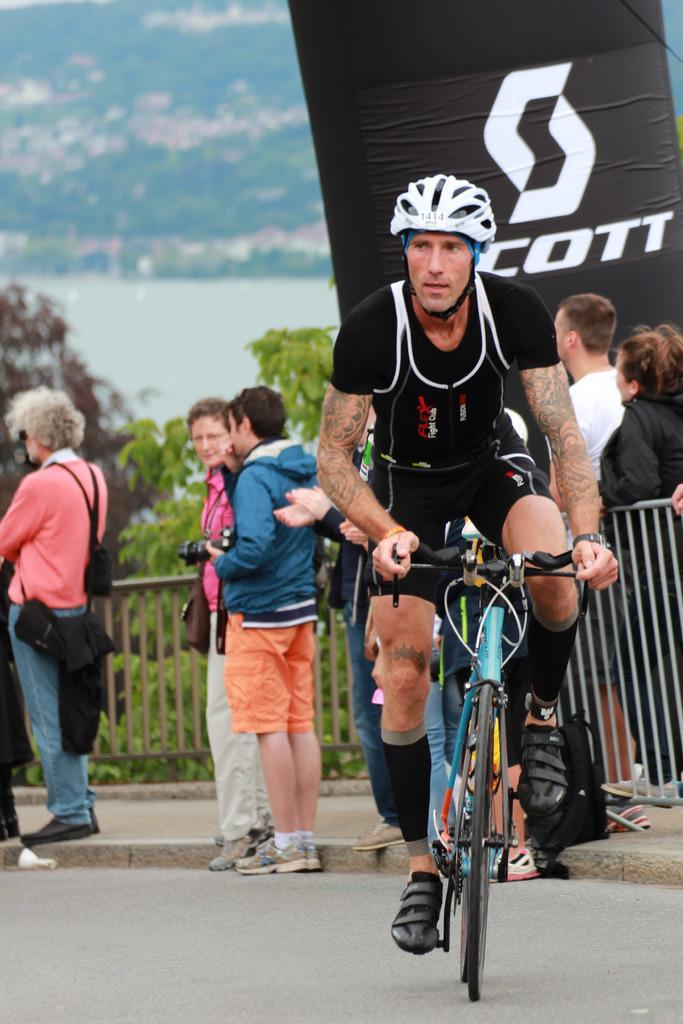Describe this image in one or two sentences. Here a man is riding a bicycle wearing a helmet. Behind him there is a black color cloth which is written in Scott and few people are standing and observing the things here it is a tree. It looks like a water. 